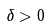<formula> <loc_0><loc_0><loc_500><loc_500>\delta > 0</formula> 